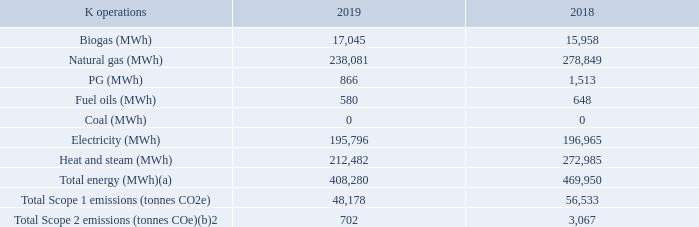Streamlined Energy and Carbon Reporting
We have decided to voluntarily comply with the UK government’s Streamlined Energy and Carbon Reporting (SECR) policy a year early. The table below represents Unilever’s energy use and associated GHG emissions from electricity and fuel in the UK for the 2018 and 2019 reporting years (1 October to 30 September), with scope calculations aligned to the Greenhouse Gas Protocol. The scope of this data includes 8 manufacturing sites and 11 non-manufacturing sites based in the UK. The UK accounts for 5% of our global total Scope 1 and 2 emissions, outlined in our mandatory GHG reporting also on this page.
(a) Fleet and associated diesel use excluded. Transportation is operated by a
third party and accounted for under Scope 3.
(b) Carbon emission factors for grid electricity calculated according to the marketbased method'
For further information on energy efficiency measures taken to reduce our carbon
emissions, please see page 19.
How is the carbon emission factor for grid calculated? Carbon emission factors for grid electricity calculated according to the marketbased method'. UK accounts for what percentage of Total Scope 1 and 2? 5%. In which scope is transportation included? Scope 3. What is the increase in the Biogas from 2018 to 2019? 17,045 - 15,958
Answer: 1087. What is the average total energy? (408,280 + 469,950) / 2
Answer: 439115. What is the percentage increase / (decrease) in Fuel Oils from 2018 to 2019?
Answer scale should be: percent. 580 / 648 - 1
Answer: -10.49. 